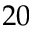Convert formula to latex. <formula><loc_0><loc_0><loc_500><loc_500>2 0</formula> 